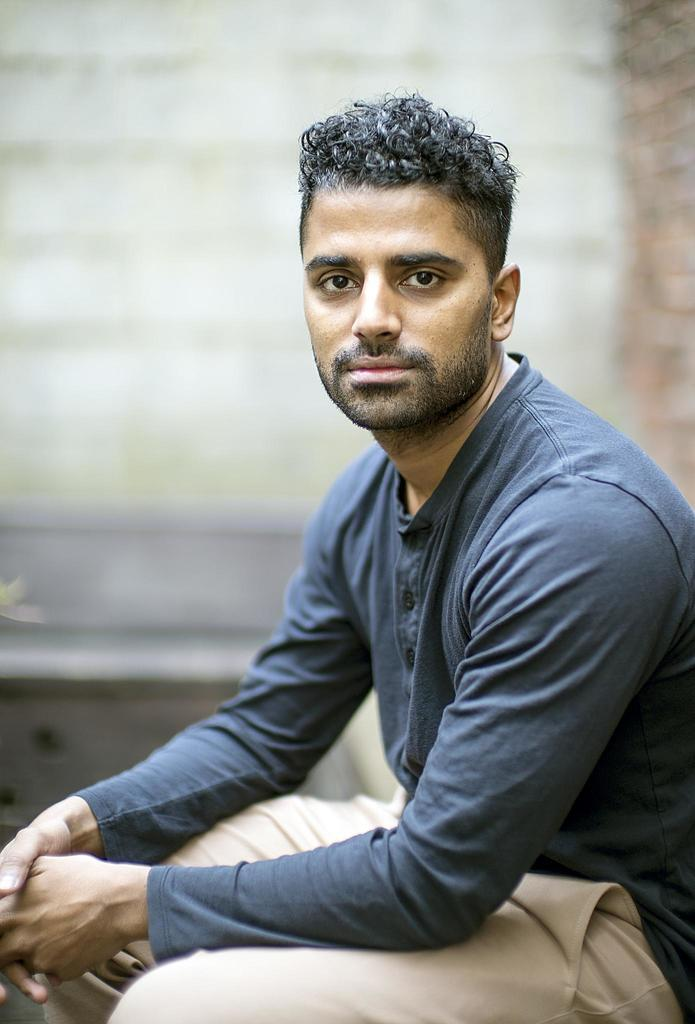What is the main subject of the image? There is a person in the image. What type of clothing is the person wearing? The person is wearing a T-shirt and trousers. What is the person doing in the image? The person is sitting. Can you describe the background of the image? The background of the image is blurred. What type of potato is the person holding in the image? There is no potato present in the image. What subject is being taught in the school setting depicted in the image? There is no school setting or subject being taught in the image. 